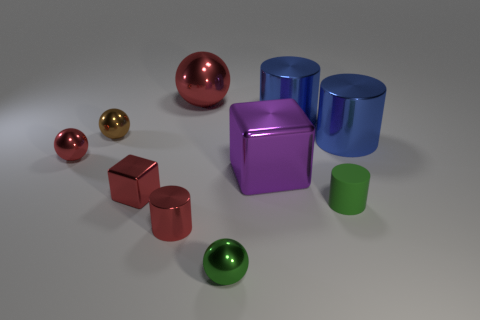How does the lighting in this image affect the appearance of the objects? The lighting in the image provides a soft overall illumination with subtle highlights and shadows, helping to accentuate the glossiness and reflective qualities of the metallic surfaces. It creates a sense of depth and realism by producing reflections and diffuse shading on the objects. 